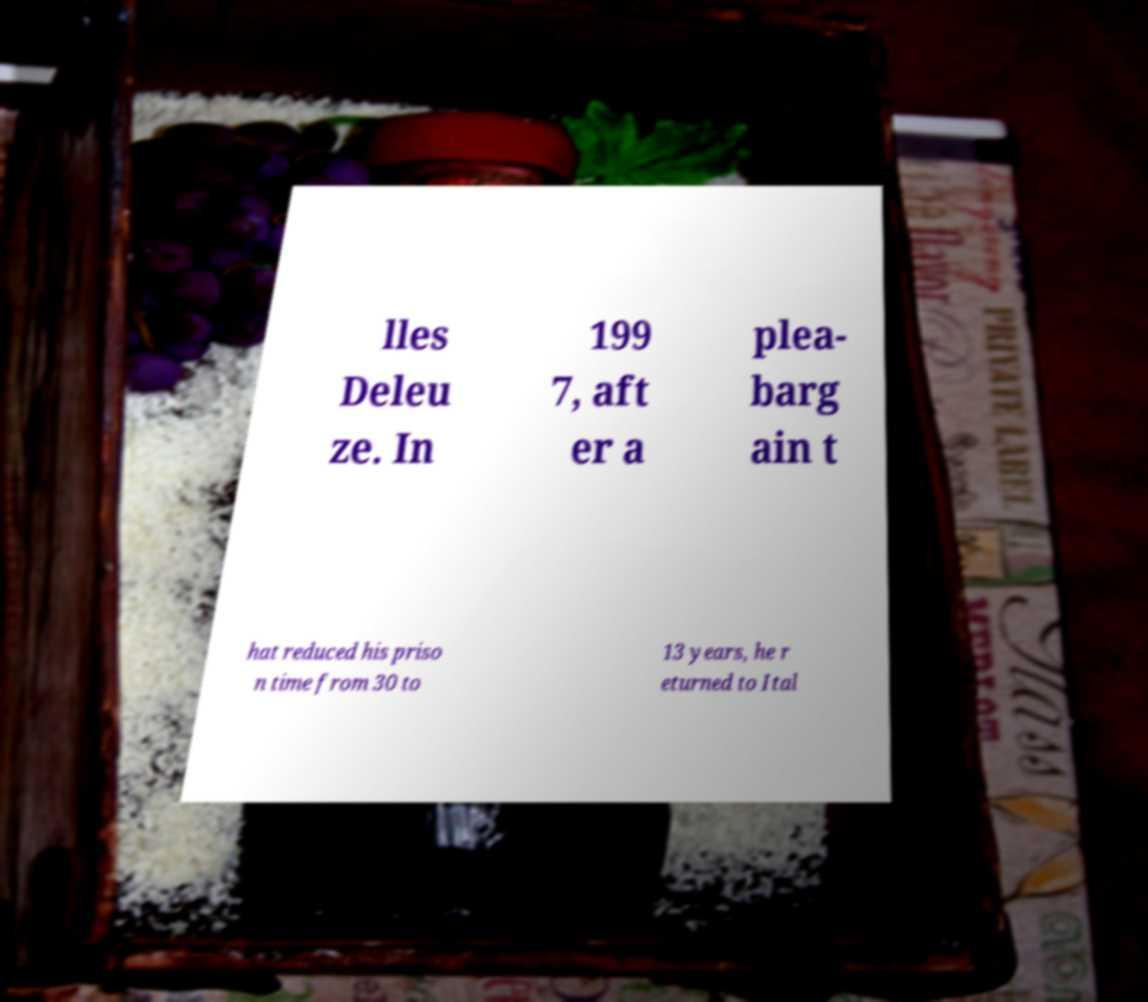I need the written content from this picture converted into text. Can you do that? lles Deleu ze. In 199 7, aft er a plea- barg ain t hat reduced his priso n time from 30 to 13 years, he r eturned to Ital 